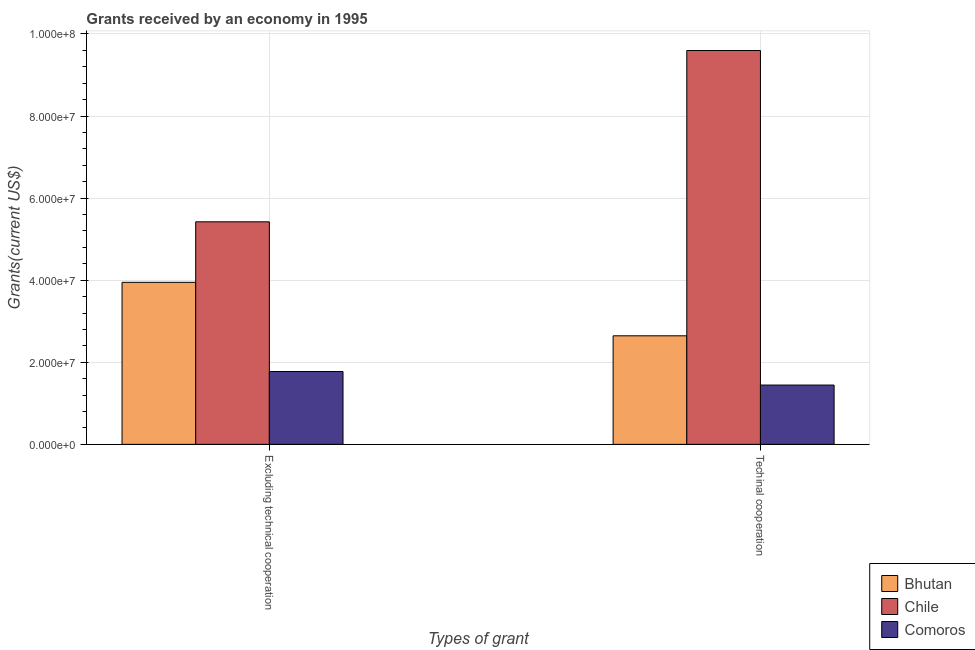How many groups of bars are there?
Make the answer very short. 2. Are the number of bars per tick equal to the number of legend labels?
Offer a very short reply. Yes. Are the number of bars on each tick of the X-axis equal?
Ensure brevity in your answer.  Yes. How many bars are there on the 2nd tick from the right?
Give a very brief answer. 3. What is the label of the 1st group of bars from the left?
Give a very brief answer. Excluding technical cooperation. What is the amount of grants received(excluding technical cooperation) in Comoros?
Keep it short and to the point. 1.78e+07. Across all countries, what is the maximum amount of grants received(including technical cooperation)?
Your response must be concise. 9.60e+07. Across all countries, what is the minimum amount of grants received(including technical cooperation)?
Keep it short and to the point. 1.44e+07. In which country was the amount of grants received(excluding technical cooperation) maximum?
Your answer should be compact. Chile. In which country was the amount of grants received(excluding technical cooperation) minimum?
Make the answer very short. Comoros. What is the total amount of grants received(excluding technical cooperation) in the graph?
Make the answer very short. 1.11e+08. What is the difference between the amount of grants received(excluding technical cooperation) in Chile and that in Bhutan?
Offer a terse response. 1.48e+07. What is the difference between the amount of grants received(excluding technical cooperation) in Comoros and the amount of grants received(including technical cooperation) in Bhutan?
Offer a terse response. -8.70e+06. What is the average amount of grants received(excluding technical cooperation) per country?
Give a very brief answer. 3.72e+07. What is the difference between the amount of grants received(excluding technical cooperation) and amount of grants received(including technical cooperation) in Comoros?
Your response must be concise. 3.30e+06. What is the ratio of the amount of grants received(including technical cooperation) in Chile to that in Bhutan?
Keep it short and to the point. 3.63. What does the 3rd bar from the right in Techinal cooperation represents?
Provide a succinct answer. Bhutan. How many countries are there in the graph?
Your answer should be very brief. 3. What is the difference between two consecutive major ticks on the Y-axis?
Keep it short and to the point. 2.00e+07. Does the graph contain grids?
Provide a succinct answer. Yes. What is the title of the graph?
Ensure brevity in your answer.  Grants received by an economy in 1995. Does "Uganda" appear as one of the legend labels in the graph?
Ensure brevity in your answer.  No. What is the label or title of the X-axis?
Your answer should be very brief. Types of grant. What is the label or title of the Y-axis?
Offer a very short reply. Grants(current US$). What is the Grants(current US$) in Bhutan in Excluding technical cooperation?
Keep it short and to the point. 3.95e+07. What is the Grants(current US$) of Chile in Excluding technical cooperation?
Offer a terse response. 5.42e+07. What is the Grants(current US$) in Comoros in Excluding technical cooperation?
Offer a very short reply. 1.78e+07. What is the Grants(current US$) of Bhutan in Techinal cooperation?
Ensure brevity in your answer.  2.64e+07. What is the Grants(current US$) in Chile in Techinal cooperation?
Offer a very short reply. 9.60e+07. What is the Grants(current US$) in Comoros in Techinal cooperation?
Give a very brief answer. 1.44e+07. Across all Types of grant, what is the maximum Grants(current US$) in Bhutan?
Your answer should be compact. 3.95e+07. Across all Types of grant, what is the maximum Grants(current US$) in Chile?
Ensure brevity in your answer.  9.60e+07. Across all Types of grant, what is the maximum Grants(current US$) in Comoros?
Provide a short and direct response. 1.78e+07. Across all Types of grant, what is the minimum Grants(current US$) of Bhutan?
Keep it short and to the point. 2.64e+07. Across all Types of grant, what is the minimum Grants(current US$) in Chile?
Provide a succinct answer. 5.42e+07. Across all Types of grant, what is the minimum Grants(current US$) in Comoros?
Give a very brief answer. 1.44e+07. What is the total Grants(current US$) of Bhutan in the graph?
Your answer should be compact. 6.59e+07. What is the total Grants(current US$) in Chile in the graph?
Your answer should be compact. 1.50e+08. What is the total Grants(current US$) in Comoros in the graph?
Offer a very short reply. 3.22e+07. What is the difference between the Grants(current US$) of Bhutan in Excluding technical cooperation and that in Techinal cooperation?
Offer a terse response. 1.30e+07. What is the difference between the Grants(current US$) in Chile in Excluding technical cooperation and that in Techinal cooperation?
Ensure brevity in your answer.  -4.17e+07. What is the difference between the Grants(current US$) in Comoros in Excluding technical cooperation and that in Techinal cooperation?
Your response must be concise. 3.30e+06. What is the difference between the Grants(current US$) of Bhutan in Excluding technical cooperation and the Grants(current US$) of Chile in Techinal cooperation?
Make the answer very short. -5.65e+07. What is the difference between the Grants(current US$) in Bhutan in Excluding technical cooperation and the Grants(current US$) in Comoros in Techinal cooperation?
Your answer should be very brief. 2.50e+07. What is the difference between the Grants(current US$) of Chile in Excluding technical cooperation and the Grants(current US$) of Comoros in Techinal cooperation?
Make the answer very short. 3.98e+07. What is the average Grants(current US$) of Bhutan per Types of grant?
Ensure brevity in your answer.  3.30e+07. What is the average Grants(current US$) in Chile per Types of grant?
Offer a terse response. 7.51e+07. What is the average Grants(current US$) in Comoros per Types of grant?
Provide a succinct answer. 1.61e+07. What is the difference between the Grants(current US$) of Bhutan and Grants(current US$) of Chile in Excluding technical cooperation?
Offer a terse response. -1.48e+07. What is the difference between the Grants(current US$) of Bhutan and Grants(current US$) of Comoros in Excluding technical cooperation?
Your response must be concise. 2.17e+07. What is the difference between the Grants(current US$) in Chile and Grants(current US$) in Comoros in Excluding technical cooperation?
Ensure brevity in your answer.  3.65e+07. What is the difference between the Grants(current US$) of Bhutan and Grants(current US$) of Chile in Techinal cooperation?
Your response must be concise. -6.95e+07. What is the difference between the Grants(current US$) of Chile and Grants(current US$) of Comoros in Techinal cooperation?
Ensure brevity in your answer.  8.15e+07. What is the ratio of the Grants(current US$) in Bhutan in Excluding technical cooperation to that in Techinal cooperation?
Your answer should be compact. 1.49. What is the ratio of the Grants(current US$) in Chile in Excluding technical cooperation to that in Techinal cooperation?
Provide a succinct answer. 0.57. What is the ratio of the Grants(current US$) in Comoros in Excluding technical cooperation to that in Techinal cooperation?
Offer a very short reply. 1.23. What is the difference between the highest and the second highest Grants(current US$) of Bhutan?
Your answer should be very brief. 1.30e+07. What is the difference between the highest and the second highest Grants(current US$) in Chile?
Your answer should be compact. 4.17e+07. What is the difference between the highest and the second highest Grants(current US$) in Comoros?
Offer a terse response. 3.30e+06. What is the difference between the highest and the lowest Grants(current US$) of Bhutan?
Offer a terse response. 1.30e+07. What is the difference between the highest and the lowest Grants(current US$) of Chile?
Your response must be concise. 4.17e+07. What is the difference between the highest and the lowest Grants(current US$) of Comoros?
Make the answer very short. 3.30e+06. 